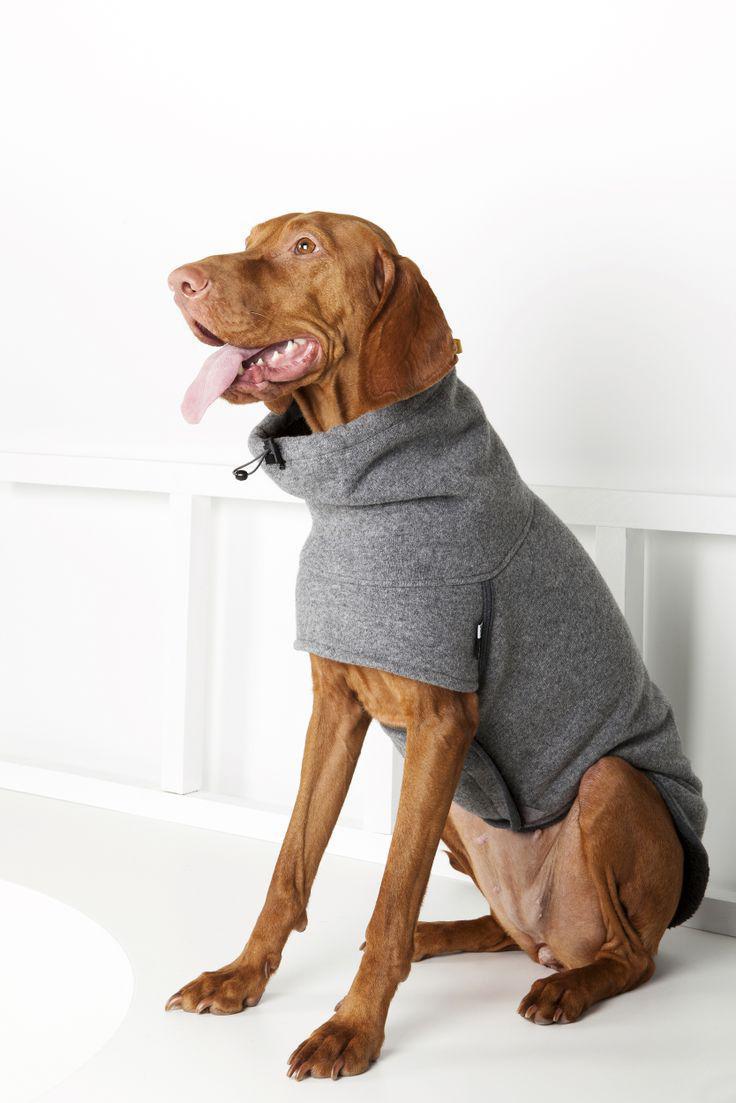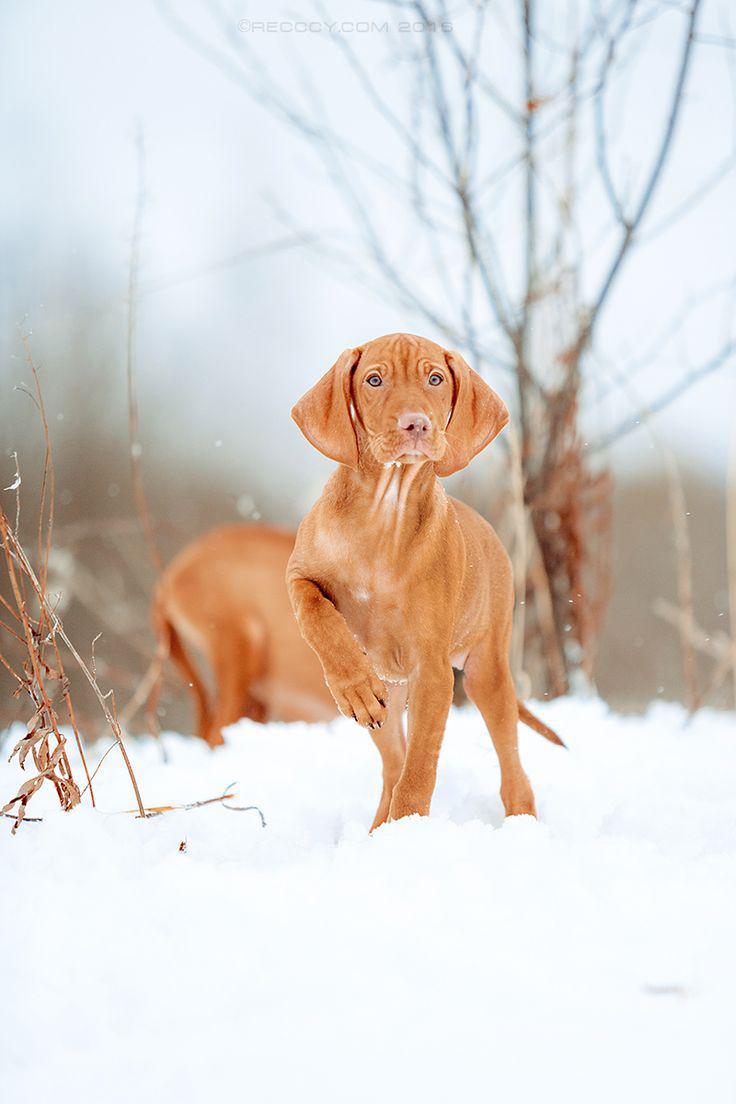The first image is the image on the left, the second image is the image on the right. Analyze the images presented: Is the assertion "The dogs in the left and right images face toward each other, and the combined images include a chocolate lab and and a red-orange lab." valid? Answer yes or no. No. The first image is the image on the left, the second image is the image on the right. Assess this claim about the two images: "At least one of the dogs is wearing something.". Correct or not? Answer yes or no. Yes. 